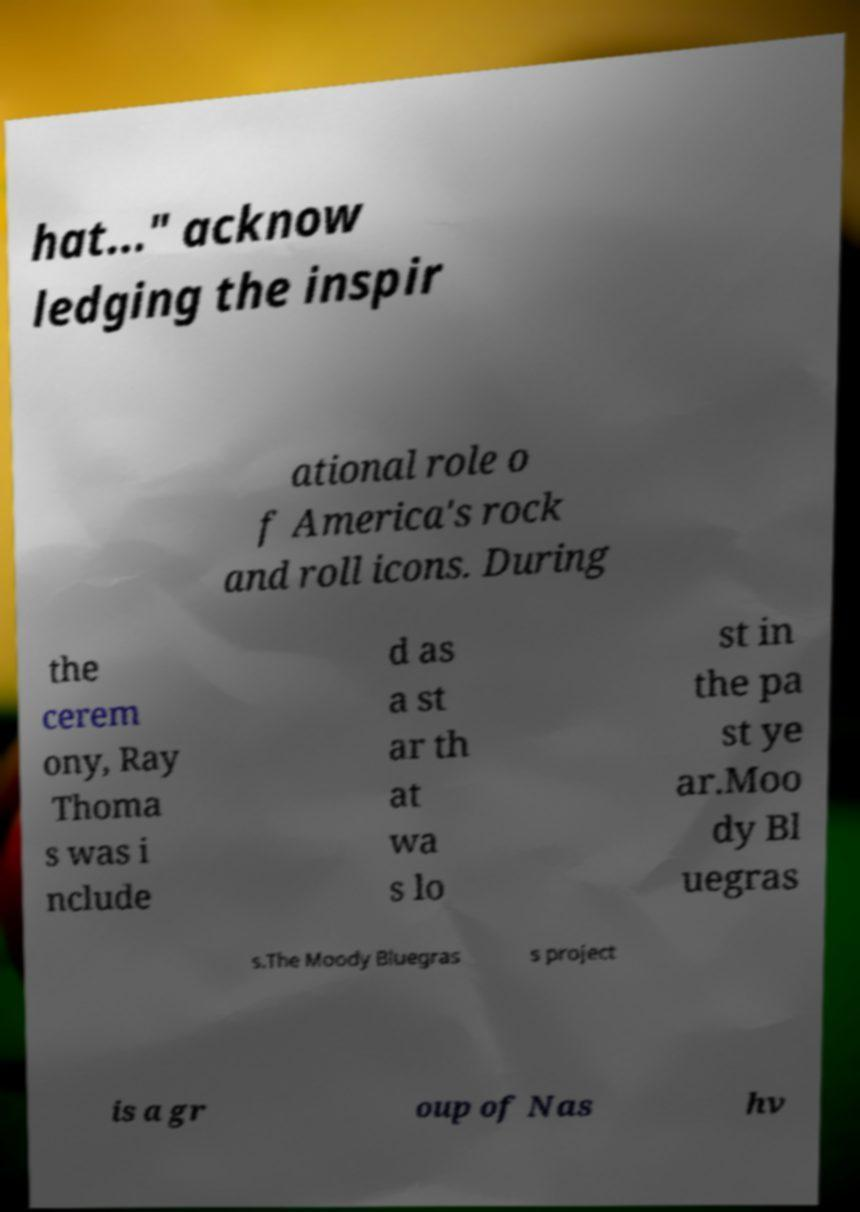There's text embedded in this image that I need extracted. Can you transcribe it verbatim? hat..." acknow ledging the inspir ational role o f America's rock and roll icons. During the cerem ony, Ray Thoma s was i nclude d as a st ar th at wa s lo st in the pa st ye ar.Moo dy Bl uegras s.The Moody Bluegras s project is a gr oup of Nas hv 